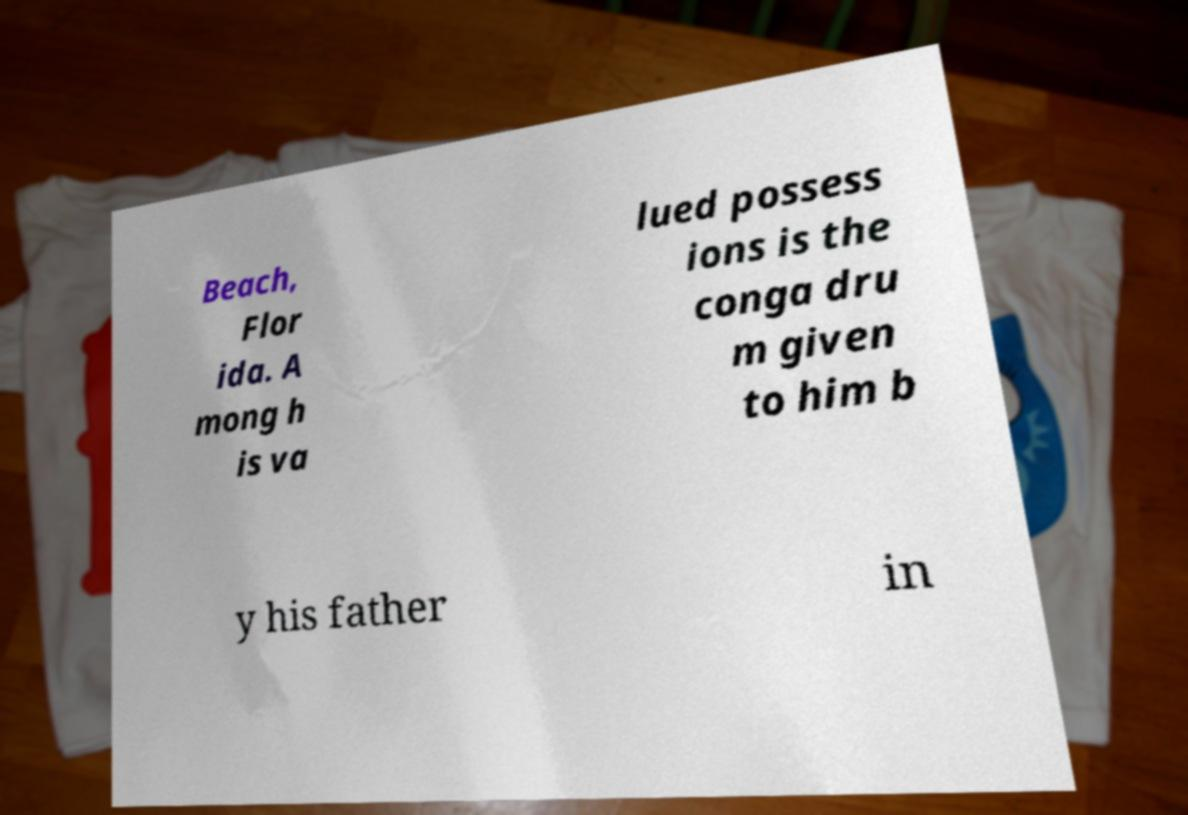There's text embedded in this image that I need extracted. Can you transcribe it verbatim? Beach, Flor ida. A mong h is va lued possess ions is the conga dru m given to him b y his father in 